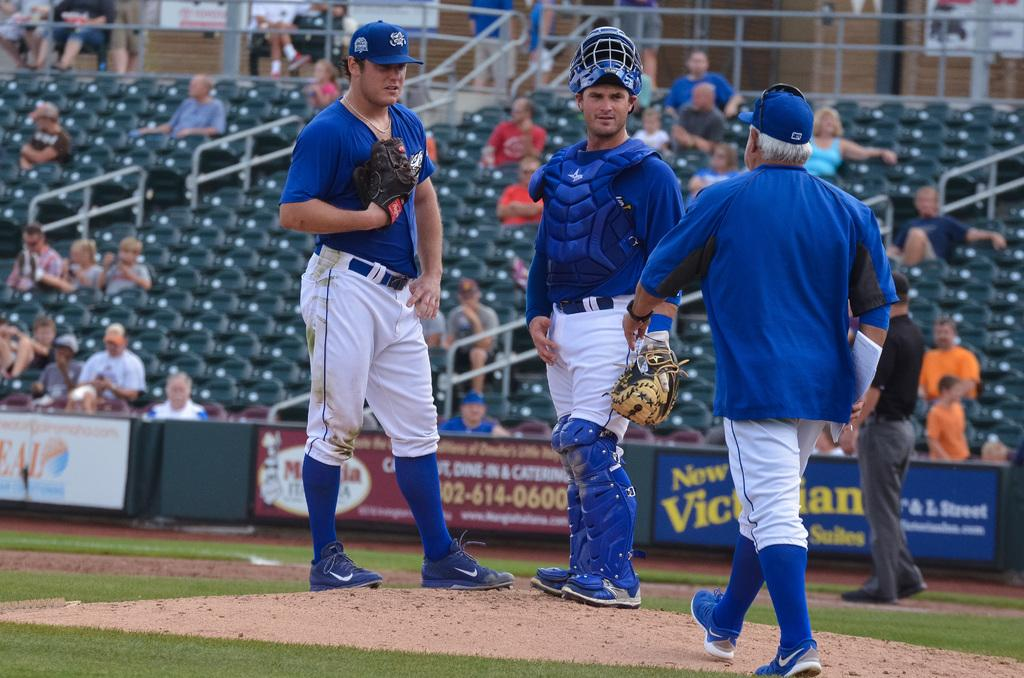<image>
Write a terse but informative summary of the picture. A pitcher wearing a Rawlings glove is being visited by the manager. 